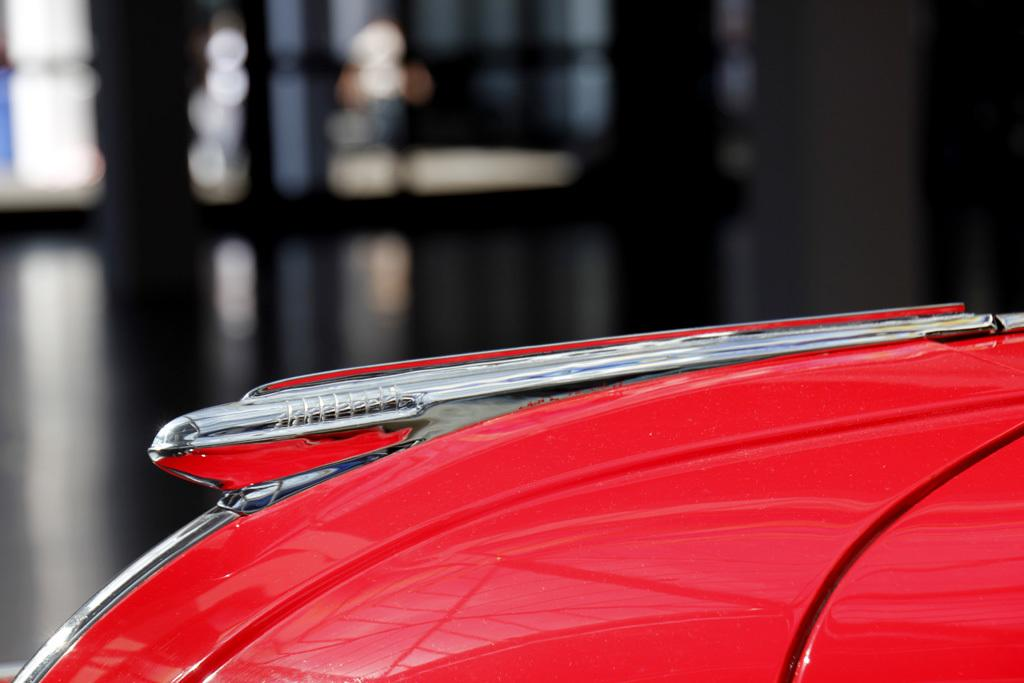What is the main subject in the image? There is a vehicle in the image. Can you describe the background of the image? The background of the image appears blurred. How many rabbits can be seen in the cave in the image? There are no rabbits or caves present in the image; it features a vehicle with a blurred background. 